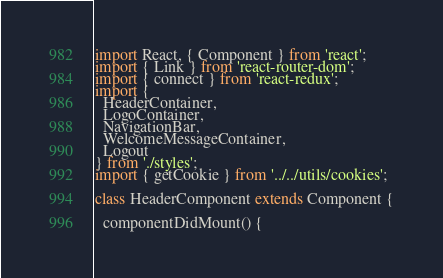Convert code to text. <code><loc_0><loc_0><loc_500><loc_500><_JavaScript_>import React, { Component } from 'react';
import { Link } from 'react-router-dom';
import { connect } from 'react-redux';
import {
  HeaderContainer,
  LogoContainer,
  NavigationBar,
  WelcomeMessageContainer,
  Logout
} from './styles';
import { getCookie } from '../../utils/cookies';

class HeaderComponent extends Component {

  componentDidMount() {</code> 